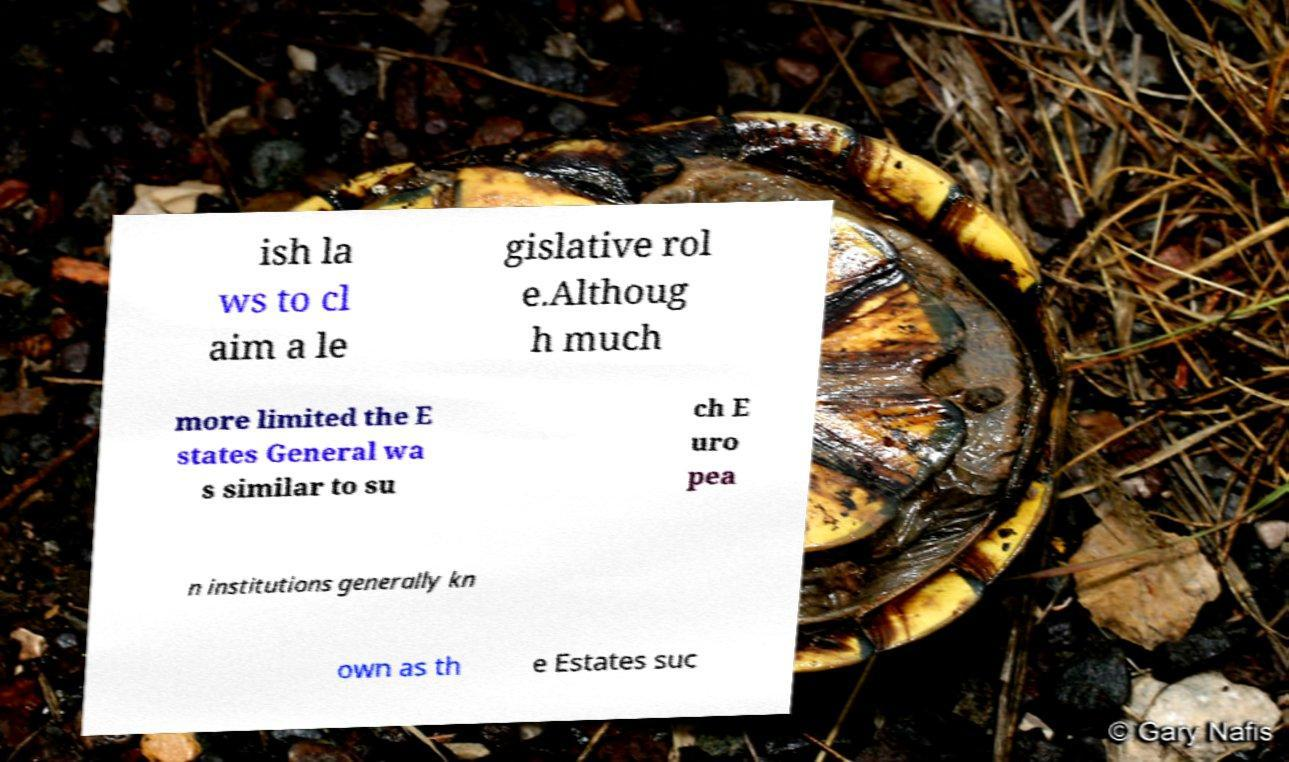I need the written content from this picture converted into text. Can you do that? ish la ws to cl aim a le gislative rol e.Althoug h much more limited the E states General wa s similar to su ch E uro pea n institutions generally kn own as th e Estates suc 